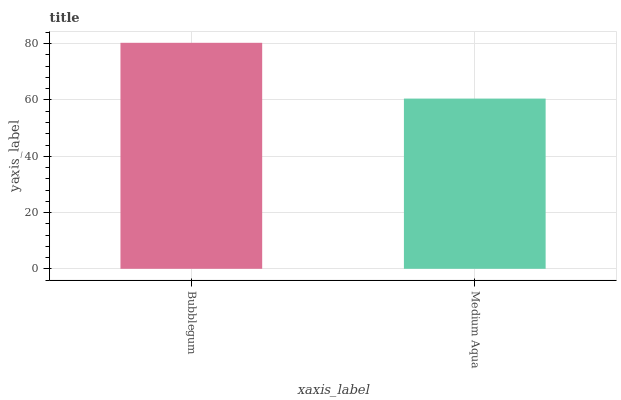Is Medium Aqua the minimum?
Answer yes or no. Yes. Is Bubblegum the maximum?
Answer yes or no. Yes. Is Medium Aqua the maximum?
Answer yes or no. No. Is Bubblegum greater than Medium Aqua?
Answer yes or no. Yes. Is Medium Aqua less than Bubblegum?
Answer yes or no. Yes. Is Medium Aqua greater than Bubblegum?
Answer yes or no. No. Is Bubblegum less than Medium Aqua?
Answer yes or no. No. Is Bubblegum the high median?
Answer yes or no. Yes. Is Medium Aqua the low median?
Answer yes or no. Yes. Is Medium Aqua the high median?
Answer yes or no. No. Is Bubblegum the low median?
Answer yes or no. No. 